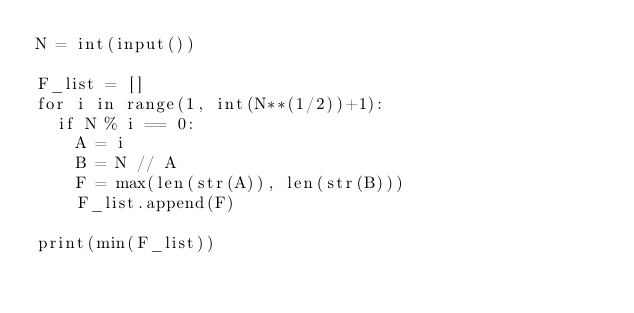Convert code to text. <code><loc_0><loc_0><loc_500><loc_500><_Python_>N = int(input())

F_list = []
for i in range(1, int(N**(1/2))+1):
  if N % i == 0:
    A = i
    B = N // A
    F = max(len(str(A)), len(str(B)))
    F_list.append(F)

print(min(F_list))
</code> 